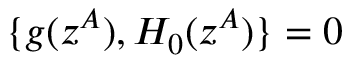<formula> <loc_0><loc_0><loc_500><loc_500>\{ g ( z ^ { A } ) , H _ { 0 } ( z ^ { A } ) \} = 0</formula> 